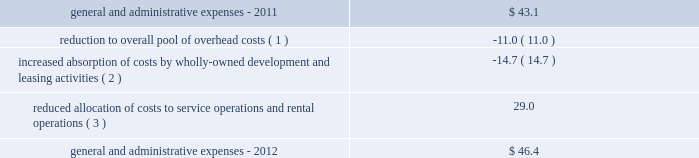29 annual report 2012 duke realty corporation | | those indirect costs not allocated to or absorbed by these operations are charged to general and administrative expenses .
We regularly review our total overhead cost structure relative to our leasing , development and construction volume and adjust the level of total overhead , generally through changes in our level of staffing in various functional departments , as necessary in order to control overall general and administrative expense .
General and administrative expenses increased from $ 43.1 million in 2011 to $ 46.4 million in 2012 .
The table sets forth the factors that led to the increase in general and administrative expenses from 2011 to 2012 ( in millions ) : .
( 1 ) we reduced our total pool of overhead costs , through staff reductions and other measures , as the result of changes in our product mix and anticipated future levels of third-party construction , leasing , management and other operational activities .
( 2 ) we increased our focus on development of wholly-owned properties , and also significantly increased our leasing activity during 2012 , which resulted in an increased absorption of overhead costs .
We capitalized $ 30.4 million and $ 20.0 million of our total overhead costs to leasing and development , respectively , for consolidated properties during 2012 , compared to capitalizing $ 25.3 million and $ 10.4 million of such costs , respectively , for 2011 .
Combined overhead costs capitalized to leasing and development totaled 31.1% ( 31.1 % ) and 20.6% ( 20.6 % ) of our overall pool of overhead costs for 2012 and 2011 , respectively .
( 3 ) the reduction in the allocation of overhead costs to service operations and rental operations resulted from reduced volumes of third-party construction projects as well as due to reducing our overall investment in office properties , which are more management intensive .
Interest expense interest expense allocable to continuing operations increased from $ 220.5 million in 2011 to $ 245.2 million in 2012 .
We had $ 47.4 million of interest expense allocated to discontinued operations in 2011 , associated with the properties that were disposed of during 2011 , compared to the allocation of only $ 3.1 million of interest expense to discontinued operations for 2012 .
Total interest expense , combined for continuing and discontinued operations , decreased from $ 267.8 million in 2011 to $ 248.3 million in 2012 .
The reduction in total interest expense was primarily the result of a lower weighted average borrowing rate in 2012 , due to refinancing some higher rate bonds in 2011 and 2012 , as well as a slight decrease in our average level of borrowings compared to 2011 .
Also , due to an increase in properties under development from 2011 , which met the criteria for capitalization of interest and were financed in part by common equity issuances during 2012 , a $ 5.0 million increase in capitalized interest also contributed to the decrease in total interest expense in 2012 .
Acquisition-related activity during 2012 , we recognized approximately $ 4.2 million in acquisition costs , compared to $ 2.3 million of such costs in 2011 .
The increase from 2011 to 2012 is the result of acquiring a higher volume of medical office properties , where a higher level of acquisition costs are incurred than other property types , in 2012 .
During 2011 , we also recognized a $ 1.1 million gain related to the acquisition of a building from one of our 50%-owned unconsolidated joint ventures .
Discontinued operations subject to certain criteria , the results of operations for properties sold during the year to unrelated parties , or classified as held-for-sale at the end of the period , are required to be classified as discontinued operations .
The property specific components of earnings that are classified as discontinued operations include rental revenues , rental expenses , real estate taxes , allocated interest expense and depreciation expense , as well as the net gain or loss on the disposition of properties .
The operations of 150 buildings are currently classified as discontinued operations .
These 150 buildings consist of 114 office , 30 industrial , four retail , and two medical office properties .
As a result , we classified operating losses , before gain on sales , of $ 1.5 million , $ 1.8 million and $ 7.1 million in discontinued operations for the years ended december 31 , 2012 , 2011 and 2010 , respectively .
Of these properties , 28 were sold during 2012 , 101 properties were sold during 2011 and 19 properties were sold during 2010 .
The gains on disposal of these properties of $ 13.5 million , $ 100.9 million and $ 33.1 million for the years ended december 31 , 2012 , 2011 and .
What was the percent increase of the interest expense allocable to continuing operations in 2012 to 2011? 
Computations: ((245.2 - 220.5) / 220.5)
Answer: 0.11202. 